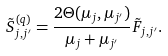<formula> <loc_0><loc_0><loc_500><loc_500>\tilde { S } ^ { ( q ) } _ { j , j ^ { \prime } } = \frac { 2 \Theta ( \mu _ { j } , \mu _ { j ^ { \prime } } ) } { \mu _ { j } + \mu _ { j ^ { \prime } } } \tilde { F } _ { j , j ^ { \prime } } .</formula> 